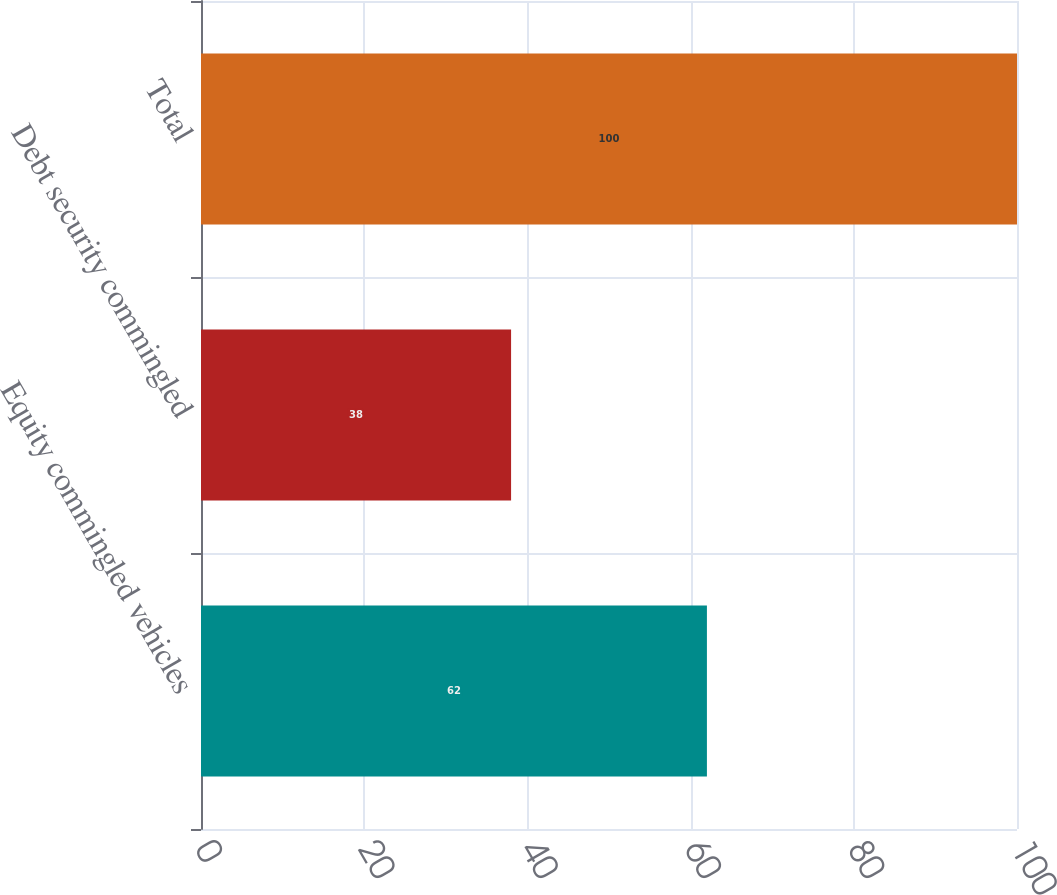Convert chart to OTSL. <chart><loc_0><loc_0><loc_500><loc_500><bar_chart><fcel>Equity commingled vehicles<fcel>Debt security commingled<fcel>Total<nl><fcel>62<fcel>38<fcel>100<nl></chart> 